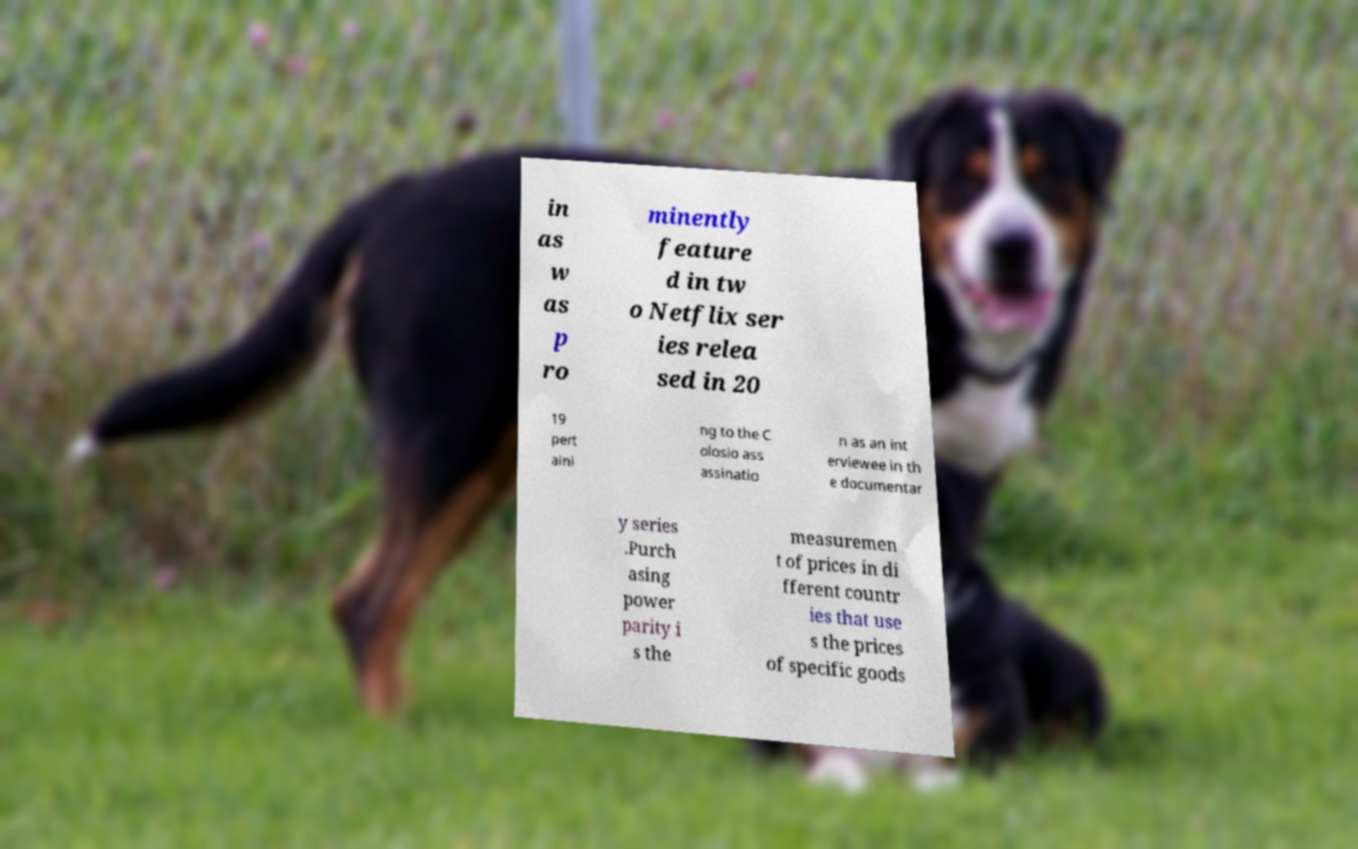Could you assist in decoding the text presented in this image and type it out clearly? in as w as p ro minently feature d in tw o Netflix ser ies relea sed in 20 19 pert aini ng to the C olosio ass assinatio n as an int erviewee in th e documentar y series .Purch asing power parity i s the measuremen t of prices in di fferent countr ies that use s the prices of specific goods 